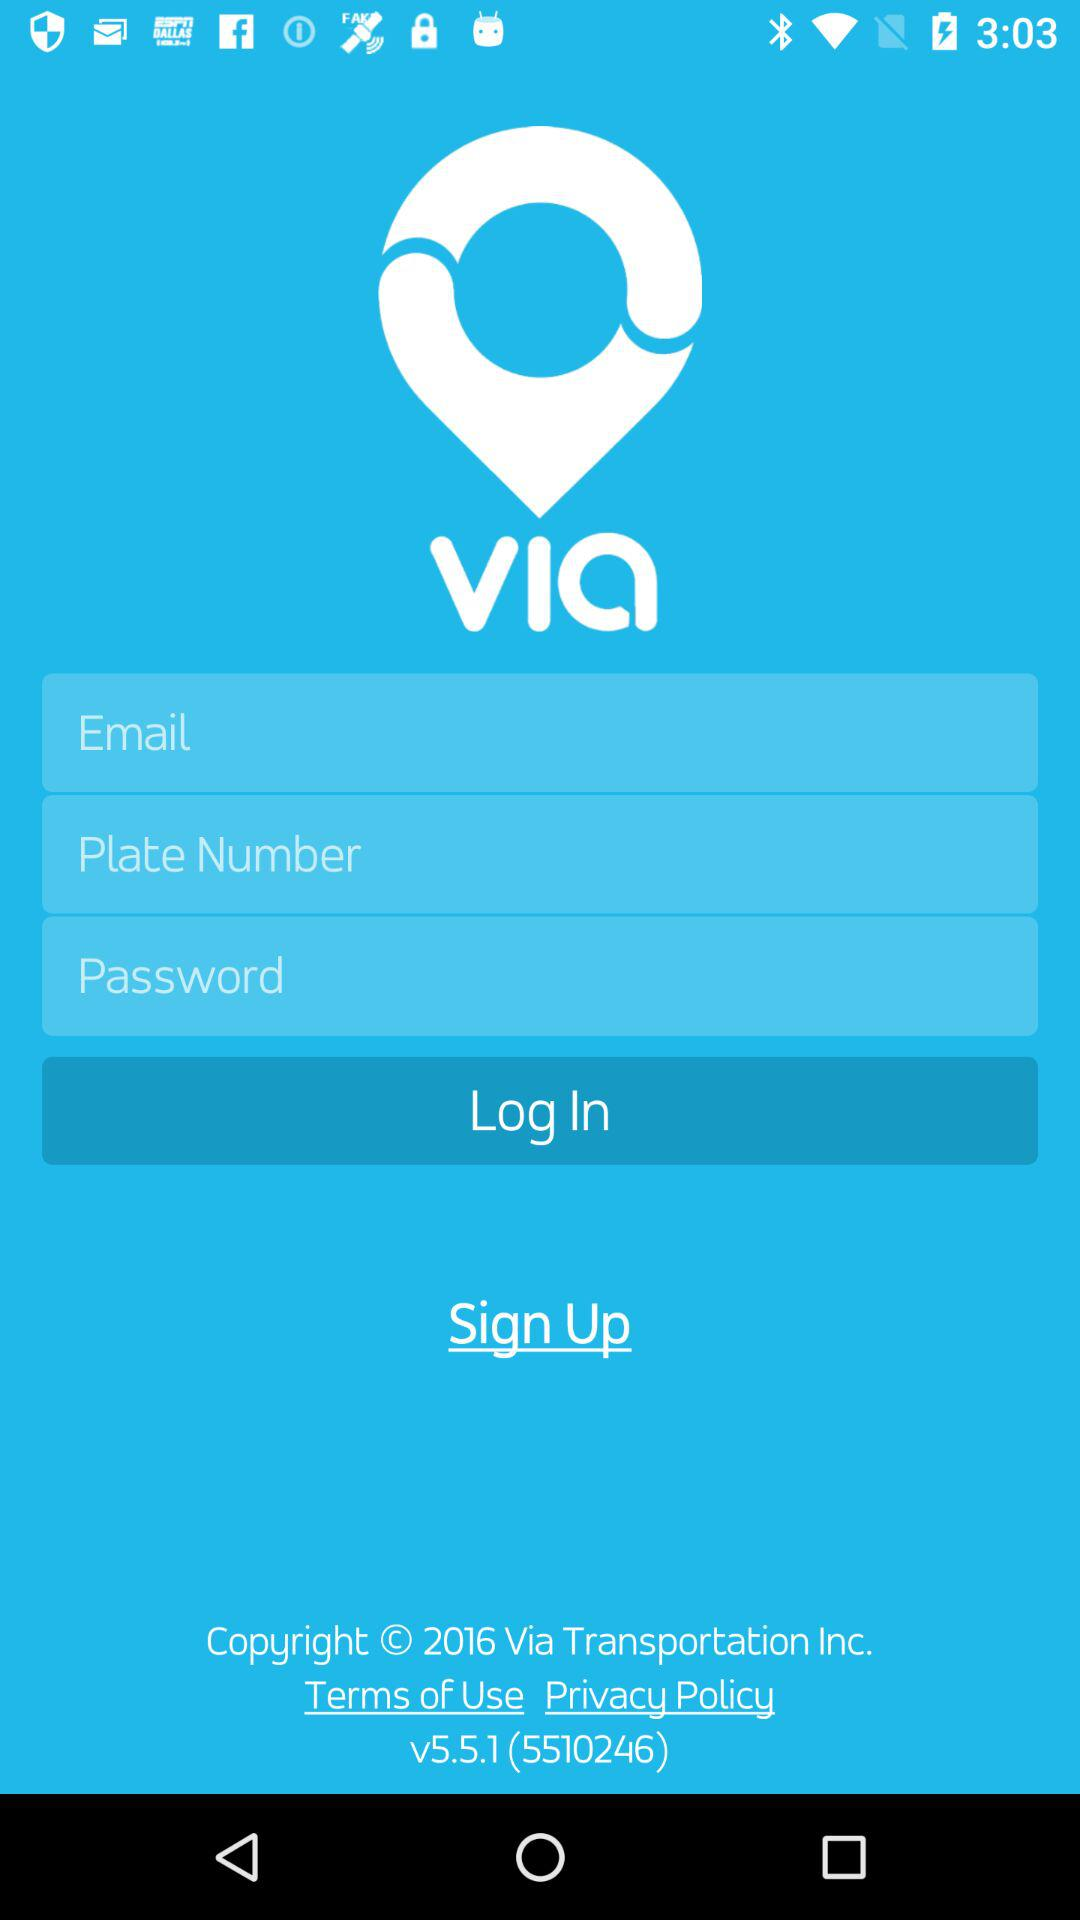Which is the given version? The given version is v5.5.1 (5510246). 